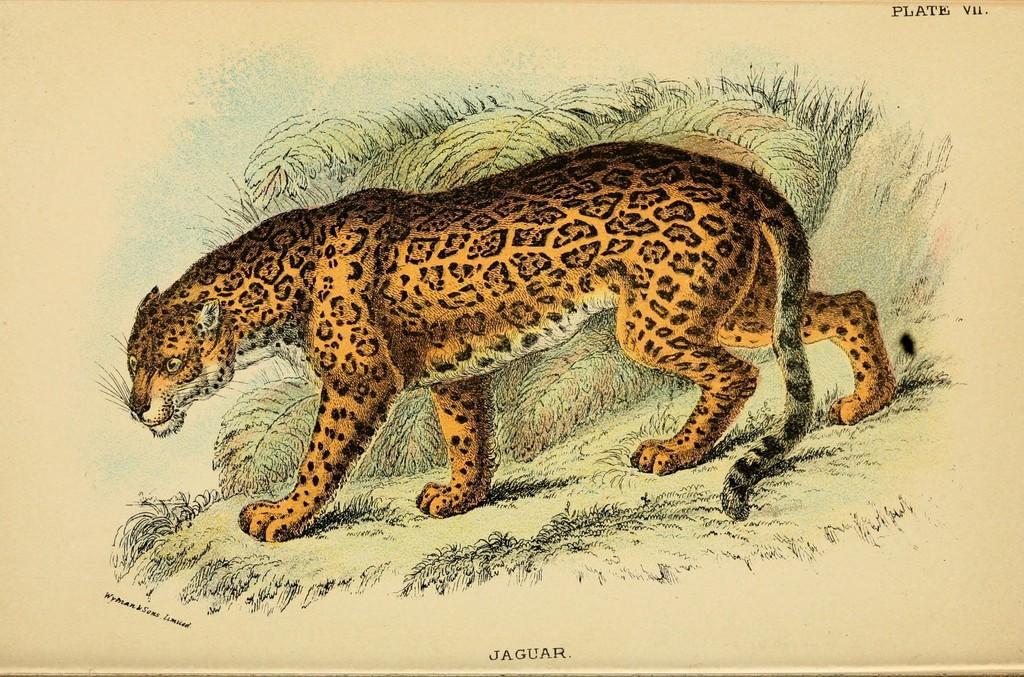How would you summarize this image in a sentence or two? In this image we can see the poster with an animal and there is the design drawn on the poster. And there is the text written on the poster. 